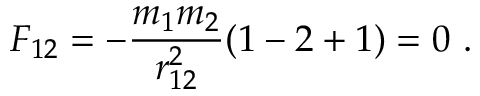<formula> <loc_0><loc_0><loc_500><loc_500>F _ { 1 2 } = - \frac { m _ { 1 } m _ { 2 } } { r _ { 1 2 } ^ { 2 } } ( 1 - 2 + 1 ) = 0 \ .</formula> 